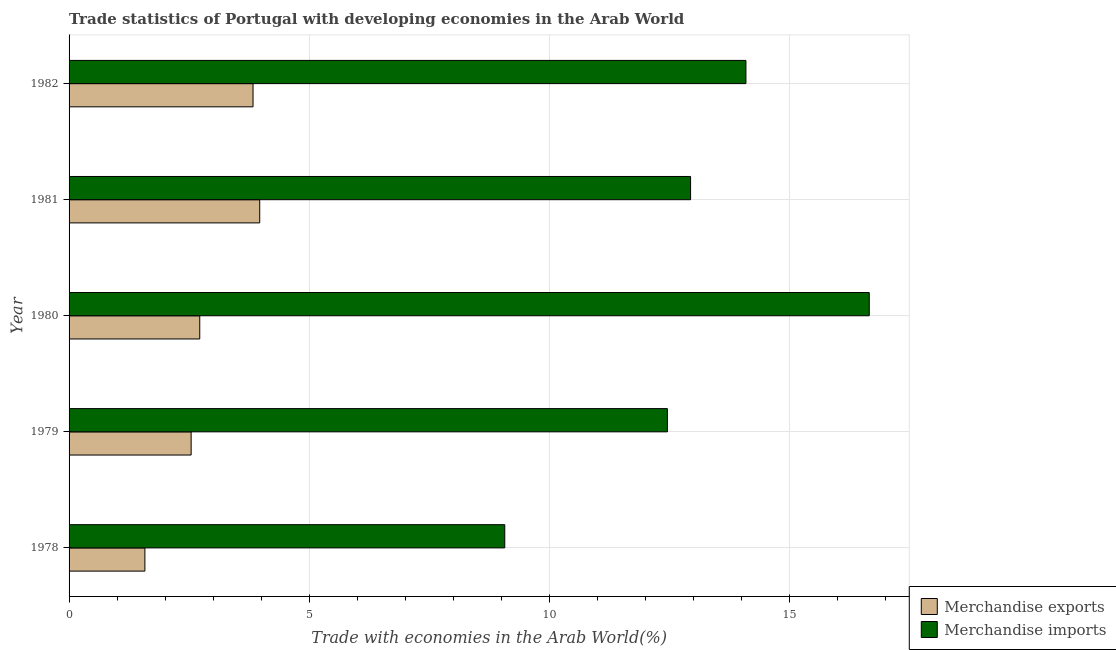What is the label of the 2nd group of bars from the top?
Give a very brief answer. 1981. What is the merchandise exports in 1982?
Make the answer very short. 3.83. Across all years, what is the maximum merchandise imports?
Provide a succinct answer. 16.66. Across all years, what is the minimum merchandise exports?
Provide a short and direct response. 1.58. In which year was the merchandise exports maximum?
Offer a very short reply. 1981. In which year was the merchandise exports minimum?
Your answer should be very brief. 1978. What is the total merchandise exports in the graph?
Your response must be concise. 14.64. What is the difference between the merchandise exports in 1981 and that in 1982?
Your response must be concise. 0.14. What is the difference between the merchandise exports in 1978 and the merchandise imports in 1982?
Provide a succinct answer. -12.51. What is the average merchandise exports per year?
Keep it short and to the point. 2.93. In the year 1980, what is the difference between the merchandise exports and merchandise imports?
Provide a succinct answer. -13.94. What is the ratio of the merchandise imports in 1978 to that in 1981?
Provide a short and direct response. 0.7. Is the merchandise exports in 1978 less than that in 1982?
Provide a succinct answer. Yes. What is the difference between the highest and the second highest merchandise exports?
Provide a succinct answer. 0.14. What is the difference between the highest and the lowest merchandise imports?
Give a very brief answer. 7.59. In how many years, is the merchandise exports greater than the average merchandise exports taken over all years?
Offer a terse response. 2. Is the sum of the merchandise imports in 1978 and 1979 greater than the maximum merchandise exports across all years?
Ensure brevity in your answer.  Yes. What does the 1st bar from the top in 1982 represents?
Offer a very short reply. Merchandise imports. How many bars are there?
Give a very brief answer. 10. Are all the bars in the graph horizontal?
Make the answer very short. Yes. What is the difference between two consecutive major ticks on the X-axis?
Your answer should be compact. 5. Are the values on the major ticks of X-axis written in scientific E-notation?
Offer a very short reply. No. What is the title of the graph?
Provide a short and direct response. Trade statistics of Portugal with developing economies in the Arab World. Does "From World Bank" appear as one of the legend labels in the graph?
Keep it short and to the point. No. What is the label or title of the X-axis?
Offer a very short reply. Trade with economies in the Arab World(%). What is the label or title of the Y-axis?
Offer a very short reply. Year. What is the Trade with economies in the Arab World(%) in Merchandise exports in 1978?
Ensure brevity in your answer.  1.58. What is the Trade with economies in the Arab World(%) in Merchandise imports in 1978?
Your answer should be very brief. 9.07. What is the Trade with economies in the Arab World(%) of Merchandise exports in 1979?
Keep it short and to the point. 2.54. What is the Trade with economies in the Arab World(%) of Merchandise imports in 1979?
Offer a very short reply. 12.46. What is the Trade with economies in the Arab World(%) of Merchandise exports in 1980?
Offer a very short reply. 2.72. What is the Trade with economies in the Arab World(%) in Merchandise imports in 1980?
Your response must be concise. 16.66. What is the Trade with economies in the Arab World(%) in Merchandise exports in 1981?
Your answer should be very brief. 3.97. What is the Trade with economies in the Arab World(%) of Merchandise imports in 1981?
Give a very brief answer. 12.94. What is the Trade with economies in the Arab World(%) in Merchandise exports in 1982?
Keep it short and to the point. 3.83. What is the Trade with economies in the Arab World(%) of Merchandise imports in 1982?
Offer a very short reply. 14.09. Across all years, what is the maximum Trade with economies in the Arab World(%) in Merchandise exports?
Keep it short and to the point. 3.97. Across all years, what is the maximum Trade with economies in the Arab World(%) in Merchandise imports?
Offer a terse response. 16.66. Across all years, what is the minimum Trade with economies in the Arab World(%) of Merchandise exports?
Your response must be concise. 1.58. Across all years, what is the minimum Trade with economies in the Arab World(%) of Merchandise imports?
Give a very brief answer. 9.07. What is the total Trade with economies in the Arab World(%) of Merchandise exports in the graph?
Keep it short and to the point. 14.64. What is the total Trade with economies in the Arab World(%) in Merchandise imports in the graph?
Offer a very short reply. 65.22. What is the difference between the Trade with economies in the Arab World(%) of Merchandise exports in 1978 and that in 1979?
Make the answer very short. -0.96. What is the difference between the Trade with economies in the Arab World(%) of Merchandise imports in 1978 and that in 1979?
Your answer should be compact. -3.39. What is the difference between the Trade with economies in the Arab World(%) of Merchandise exports in 1978 and that in 1980?
Provide a succinct answer. -1.14. What is the difference between the Trade with economies in the Arab World(%) of Merchandise imports in 1978 and that in 1980?
Provide a short and direct response. -7.59. What is the difference between the Trade with economies in the Arab World(%) in Merchandise exports in 1978 and that in 1981?
Offer a terse response. -2.39. What is the difference between the Trade with economies in the Arab World(%) of Merchandise imports in 1978 and that in 1981?
Offer a terse response. -3.87. What is the difference between the Trade with economies in the Arab World(%) of Merchandise exports in 1978 and that in 1982?
Your response must be concise. -2.25. What is the difference between the Trade with economies in the Arab World(%) in Merchandise imports in 1978 and that in 1982?
Make the answer very short. -5.02. What is the difference between the Trade with economies in the Arab World(%) of Merchandise exports in 1979 and that in 1980?
Ensure brevity in your answer.  -0.18. What is the difference between the Trade with economies in the Arab World(%) of Merchandise imports in 1979 and that in 1980?
Make the answer very short. -4.2. What is the difference between the Trade with economies in the Arab World(%) in Merchandise exports in 1979 and that in 1981?
Offer a terse response. -1.43. What is the difference between the Trade with economies in the Arab World(%) of Merchandise imports in 1979 and that in 1981?
Keep it short and to the point. -0.48. What is the difference between the Trade with economies in the Arab World(%) of Merchandise exports in 1979 and that in 1982?
Provide a succinct answer. -1.29. What is the difference between the Trade with economies in the Arab World(%) of Merchandise imports in 1979 and that in 1982?
Provide a short and direct response. -1.64. What is the difference between the Trade with economies in the Arab World(%) in Merchandise exports in 1980 and that in 1981?
Offer a terse response. -1.25. What is the difference between the Trade with economies in the Arab World(%) of Merchandise imports in 1980 and that in 1981?
Your response must be concise. 3.72. What is the difference between the Trade with economies in the Arab World(%) of Merchandise exports in 1980 and that in 1982?
Ensure brevity in your answer.  -1.11. What is the difference between the Trade with economies in the Arab World(%) in Merchandise imports in 1980 and that in 1982?
Make the answer very short. 2.57. What is the difference between the Trade with economies in the Arab World(%) in Merchandise exports in 1981 and that in 1982?
Make the answer very short. 0.14. What is the difference between the Trade with economies in the Arab World(%) in Merchandise imports in 1981 and that in 1982?
Offer a terse response. -1.15. What is the difference between the Trade with economies in the Arab World(%) in Merchandise exports in 1978 and the Trade with economies in the Arab World(%) in Merchandise imports in 1979?
Your answer should be compact. -10.88. What is the difference between the Trade with economies in the Arab World(%) in Merchandise exports in 1978 and the Trade with economies in the Arab World(%) in Merchandise imports in 1980?
Your response must be concise. -15.08. What is the difference between the Trade with economies in the Arab World(%) of Merchandise exports in 1978 and the Trade with economies in the Arab World(%) of Merchandise imports in 1981?
Offer a very short reply. -11.36. What is the difference between the Trade with economies in the Arab World(%) in Merchandise exports in 1978 and the Trade with economies in the Arab World(%) in Merchandise imports in 1982?
Ensure brevity in your answer.  -12.51. What is the difference between the Trade with economies in the Arab World(%) of Merchandise exports in 1979 and the Trade with economies in the Arab World(%) of Merchandise imports in 1980?
Your answer should be compact. -14.12. What is the difference between the Trade with economies in the Arab World(%) in Merchandise exports in 1979 and the Trade with economies in the Arab World(%) in Merchandise imports in 1981?
Offer a terse response. -10.4. What is the difference between the Trade with economies in the Arab World(%) of Merchandise exports in 1979 and the Trade with economies in the Arab World(%) of Merchandise imports in 1982?
Offer a terse response. -11.55. What is the difference between the Trade with economies in the Arab World(%) of Merchandise exports in 1980 and the Trade with economies in the Arab World(%) of Merchandise imports in 1981?
Your response must be concise. -10.22. What is the difference between the Trade with economies in the Arab World(%) of Merchandise exports in 1980 and the Trade with economies in the Arab World(%) of Merchandise imports in 1982?
Your response must be concise. -11.37. What is the difference between the Trade with economies in the Arab World(%) of Merchandise exports in 1981 and the Trade with economies in the Arab World(%) of Merchandise imports in 1982?
Make the answer very short. -10.12. What is the average Trade with economies in the Arab World(%) of Merchandise exports per year?
Ensure brevity in your answer.  2.93. What is the average Trade with economies in the Arab World(%) in Merchandise imports per year?
Provide a short and direct response. 13.04. In the year 1978, what is the difference between the Trade with economies in the Arab World(%) in Merchandise exports and Trade with economies in the Arab World(%) in Merchandise imports?
Your answer should be very brief. -7.49. In the year 1979, what is the difference between the Trade with economies in the Arab World(%) in Merchandise exports and Trade with economies in the Arab World(%) in Merchandise imports?
Your response must be concise. -9.92. In the year 1980, what is the difference between the Trade with economies in the Arab World(%) of Merchandise exports and Trade with economies in the Arab World(%) of Merchandise imports?
Your response must be concise. -13.94. In the year 1981, what is the difference between the Trade with economies in the Arab World(%) in Merchandise exports and Trade with economies in the Arab World(%) in Merchandise imports?
Your answer should be very brief. -8.97. In the year 1982, what is the difference between the Trade with economies in the Arab World(%) in Merchandise exports and Trade with economies in the Arab World(%) in Merchandise imports?
Keep it short and to the point. -10.26. What is the ratio of the Trade with economies in the Arab World(%) in Merchandise exports in 1978 to that in 1979?
Provide a short and direct response. 0.62. What is the ratio of the Trade with economies in the Arab World(%) in Merchandise imports in 1978 to that in 1979?
Ensure brevity in your answer.  0.73. What is the ratio of the Trade with economies in the Arab World(%) in Merchandise exports in 1978 to that in 1980?
Provide a short and direct response. 0.58. What is the ratio of the Trade with economies in the Arab World(%) of Merchandise imports in 1978 to that in 1980?
Ensure brevity in your answer.  0.54. What is the ratio of the Trade with economies in the Arab World(%) of Merchandise exports in 1978 to that in 1981?
Provide a succinct answer. 0.4. What is the ratio of the Trade with economies in the Arab World(%) in Merchandise imports in 1978 to that in 1981?
Provide a short and direct response. 0.7. What is the ratio of the Trade with economies in the Arab World(%) of Merchandise exports in 1978 to that in 1982?
Offer a very short reply. 0.41. What is the ratio of the Trade with economies in the Arab World(%) in Merchandise imports in 1978 to that in 1982?
Offer a terse response. 0.64. What is the ratio of the Trade with economies in the Arab World(%) in Merchandise exports in 1979 to that in 1980?
Provide a short and direct response. 0.93. What is the ratio of the Trade with economies in the Arab World(%) in Merchandise imports in 1979 to that in 1980?
Your answer should be compact. 0.75. What is the ratio of the Trade with economies in the Arab World(%) of Merchandise exports in 1979 to that in 1981?
Ensure brevity in your answer.  0.64. What is the ratio of the Trade with economies in the Arab World(%) of Merchandise imports in 1979 to that in 1981?
Make the answer very short. 0.96. What is the ratio of the Trade with economies in the Arab World(%) in Merchandise exports in 1979 to that in 1982?
Provide a short and direct response. 0.66. What is the ratio of the Trade with economies in the Arab World(%) of Merchandise imports in 1979 to that in 1982?
Make the answer very short. 0.88. What is the ratio of the Trade with economies in the Arab World(%) in Merchandise exports in 1980 to that in 1981?
Your answer should be very brief. 0.69. What is the ratio of the Trade with economies in the Arab World(%) of Merchandise imports in 1980 to that in 1981?
Keep it short and to the point. 1.29. What is the ratio of the Trade with economies in the Arab World(%) in Merchandise exports in 1980 to that in 1982?
Offer a terse response. 0.71. What is the ratio of the Trade with economies in the Arab World(%) in Merchandise imports in 1980 to that in 1982?
Your answer should be compact. 1.18. What is the ratio of the Trade with economies in the Arab World(%) in Merchandise exports in 1981 to that in 1982?
Provide a short and direct response. 1.04. What is the ratio of the Trade with economies in the Arab World(%) of Merchandise imports in 1981 to that in 1982?
Make the answer very short. 0.92. What is the difference between the highest and the second highest Trade with economies in the Arab World(%) of Merchandise exports?
Ensure brevity in your answer.  0.14. What is the difference between the highest and the second highest Trade with economies in the Arab World(%) in Merchandise imports?
Provide a short and direct response. 2.57. What is the difference between the highest and the lowest Trade with economies in the Arab World(%) of Merchandise exports?
Your answer should be compact. 2.39. What is the difference between the highest and the lowest Trade with economies in the Arab World(%) in Merchandise imports?
Offer a very short reply. 7.59. 